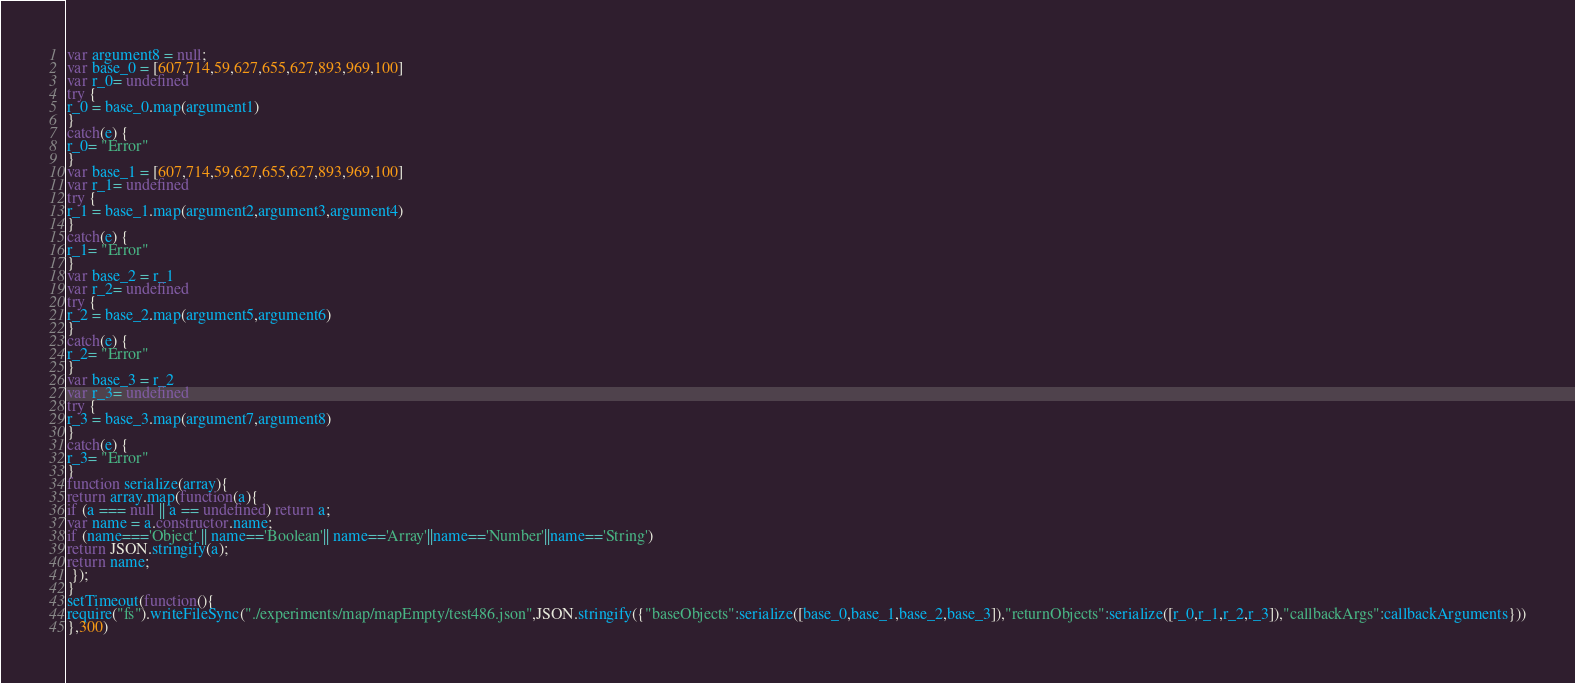<code> <loc_0><loc_0><loc_500><loc_500><_JavaScript_>var argument8 = null;
var base_0 = [607,714,59,627,655,627,893,969,100]
var r_0= undefined
try {
r_0 = base_0.map(argument1)
}
catch(e) {
r_0= "Error"
}
var base_1 = [607,714,59,627,655,627,893,969,100]
var r_1= undefined
try {
r_1 = base_1.map(argument2,argument3,argument4)
}
catch(e) {
r_1= "Error"
}
var base_2 = r_1
var r_2= undefined
try {
r_2 = base_2.map(argument5,argument6)
}
catch(e) {
r_2= "Error"
}
var base_3 = r_2
var r_3= undefined
try {
r_3 = base_3.map(argument7,argument8)
}
catch(e) {
r_3= "Error"
}
function serialize(array){
return array.map(function(a){
if (a === null || a == undefined) return a;
var name = a.constructor.name;
if (name==='Object' || name=='Boolean'|| name=='Array'||name=='Number'||name=='String')
return JSON.stringify(a);
return name;
 });
}
setTimeout(function(){
require("fs").writeFileSync("./experiments/map/mapEmpty/test486.json",JSON.stringify({"baseObjects":serialize([base_0,base_1,base_2,base_3]),"returnObjects":serialize([r_0,r_1,r_2,r_3]),"callbackArgs":callbackArguments}))
},300)</code> 